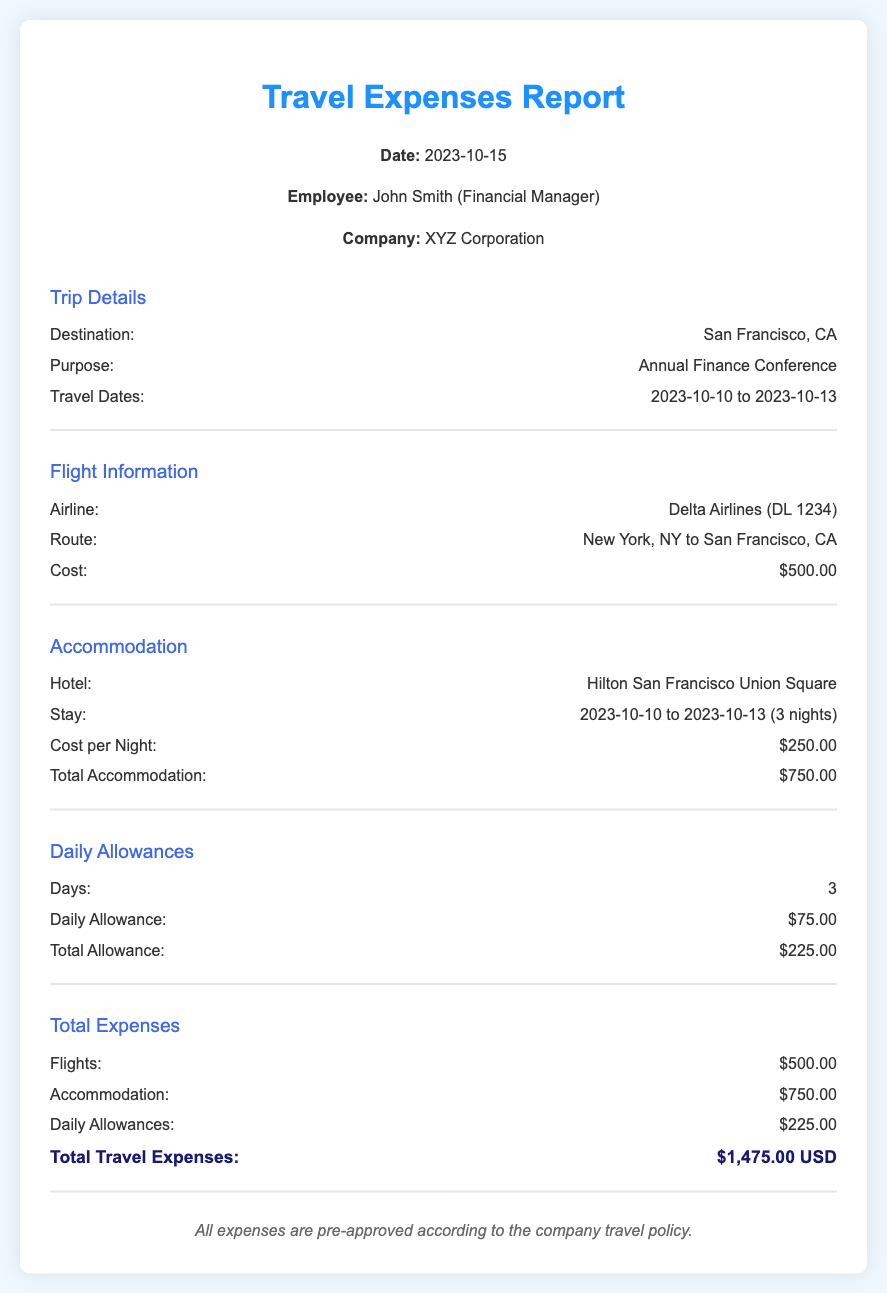What is the total travel expenses? The total travel expenses is calculated by adding all individual expenses: flights, accommodation, and daily allowances. The total is $500.00 + $750.00 + $225.00 = $1,475.00.
Answer: $1,475.00 USD How many nights did John Smith stay at the hotel? The document states that John Smith stayed from October 10 to October 13, which is a total of 3 nights.
Answer: 3 nights What was the airline used for the flight? The document specifies the airline as Delta Airlines.
Answer: Delta Airlines What is the cost of the flight? The document shows that the flight cost is $500.00.
Answer: $500.00 What is the daily allowance amount? The daily allowance mentioned in the document is $75.00.
Answer: $75.00 Which hotel did John Smith stay at? The document specifies that John Smith stayed at Hilton San Francisco Union Square.
Answer: Hilton San Francisco Union Square What was the total accommodation cost? The document lists the total accommodation cost as $750.00.
Answer: $750.00 What is the total amount for daily allowances? The total for daily allowances in the document is given as $225.00.
Answer: $225.00 What was the purpose of the trip? According to the document, the purpose of the trip was to attend the Annual Finance Conference.
Answer: Annual Finance Conference 